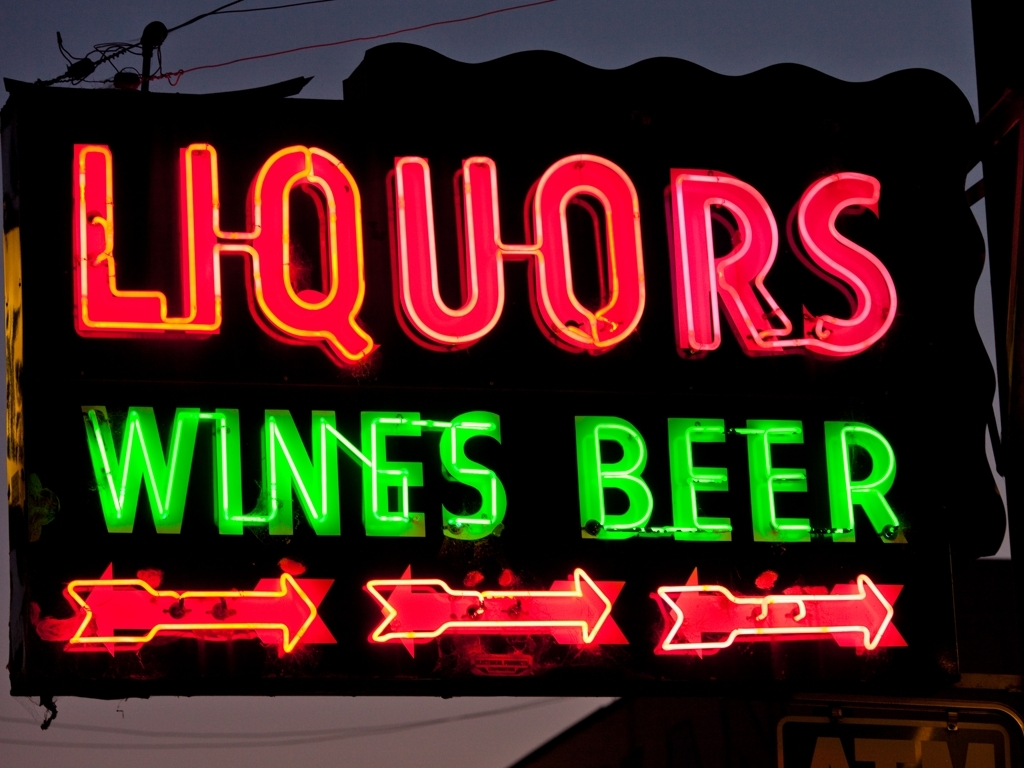What could be the significance of the colors used in this sign? The colors used in this neon sign—red for 'LIQUORS', green for 'WINES', and yellow for 'BEER'—are likely chosen for their visibility and psychological impact. Red can grab attention and signals excitement, green often represents freshness, and yellow can evoke happiness and is easily seen from a distance. How do the arrows on the sign affect its overall design? The arrows add a dynamic element to the sign, possibly suggesting direction or movement. It may imply that the store offers a wide range of options in liquors, wines, and beer, leading customers to different sections of the store or encouraging them to explore the variety available. 